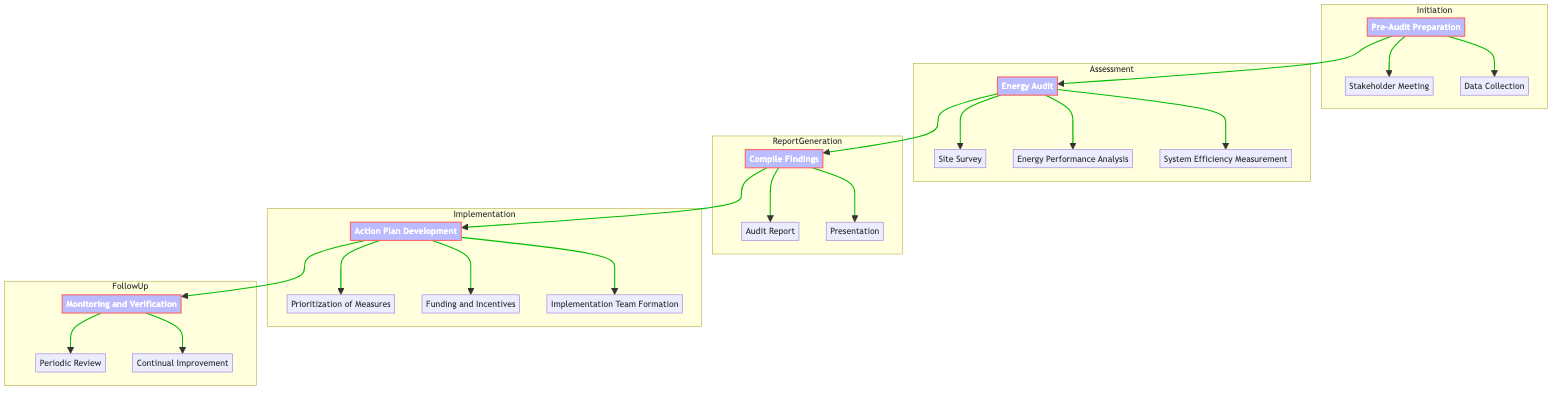What is the first step in the Clinical Pathway? The first step in the Clinical Pathway is labeled as "Pre-Audit Preparation."
Answer: Pre-Audit Preparation How many actions are in the Assessment phase? The Assessment phase has three actions: Site Survey, Energy Performance Analysis, and System Efficiency Measurement, totaling three actions.
Answer: 3 What action comes after Data Collection? After Data Collection in the Initiation phase, the next step is the Energy Audit phase.
Answer: Energy Audit What is the last action in the Follow-Up phase? The last action in the Follow-Up phase is "Continual Improvement." This is derived from the sequence of actions listed under the Follow-Up subgraph.
Answer: Continual Improvement Which phase includes the action "Presentation"? The action "Presentation" is found in the Report Generation phase. This can be confirmed by examining the arranged actions within the respective phases of the diagram.
Answer: Report Generation How many total actions are in the Implementation phase? The Implementation phase comprises three actions: Prioritization of Measures, Funding and Incentives, and Implementation Team Formation, indicating a count of three actions.
Answer: 3 What comes immediately after the Audit Report? The action that comes immediately after the Audit Report is "Presentation," indicating that both actions are part of compiling findings in the Report Generation phase.
Answer: Presentation Which step follows the energy audit? Following the energy audit, the next step is to Compile Findings, as indicated by the flow from the Assessment to Report Generation phases.
Answer: Compile Findings What is the main focus of the Monitoring and Verification step? The main focus of the Monitoring and Verification step is to ensure sustained savings through a Periodic Review and Continual Improvement, indicating a theme of ongoing assessment.
Answer: Sustained savings 